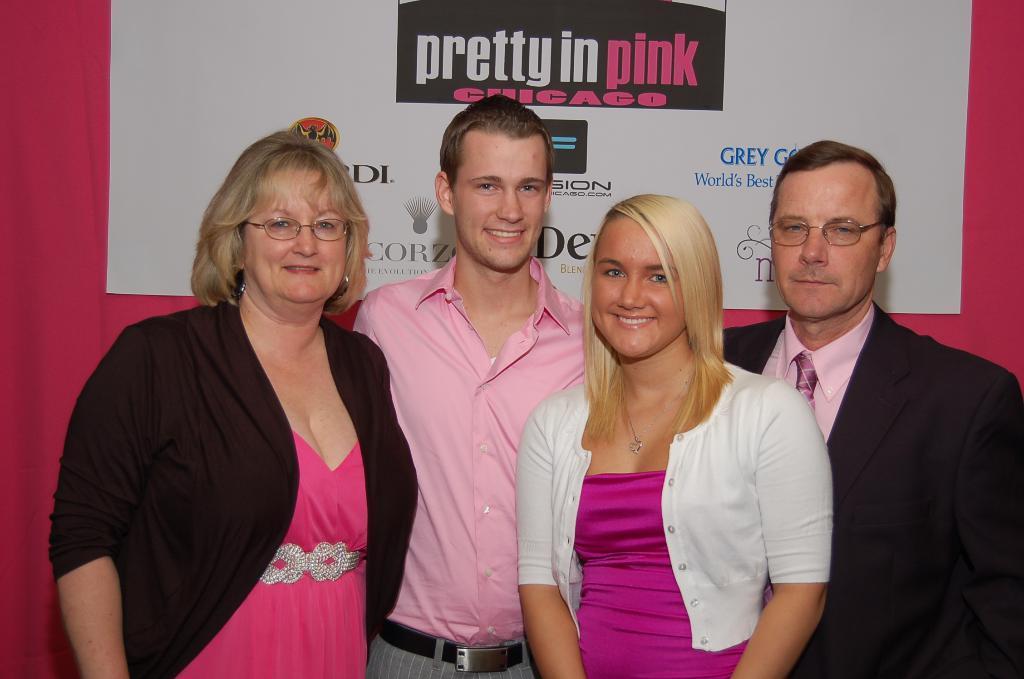Describe this image in one or two sentences. Here I can see two women and two men are standing, smiling and giving pose for the picture. At the back of these people there is a curtain. At the top of the image there is a white board on which I can see some text. 